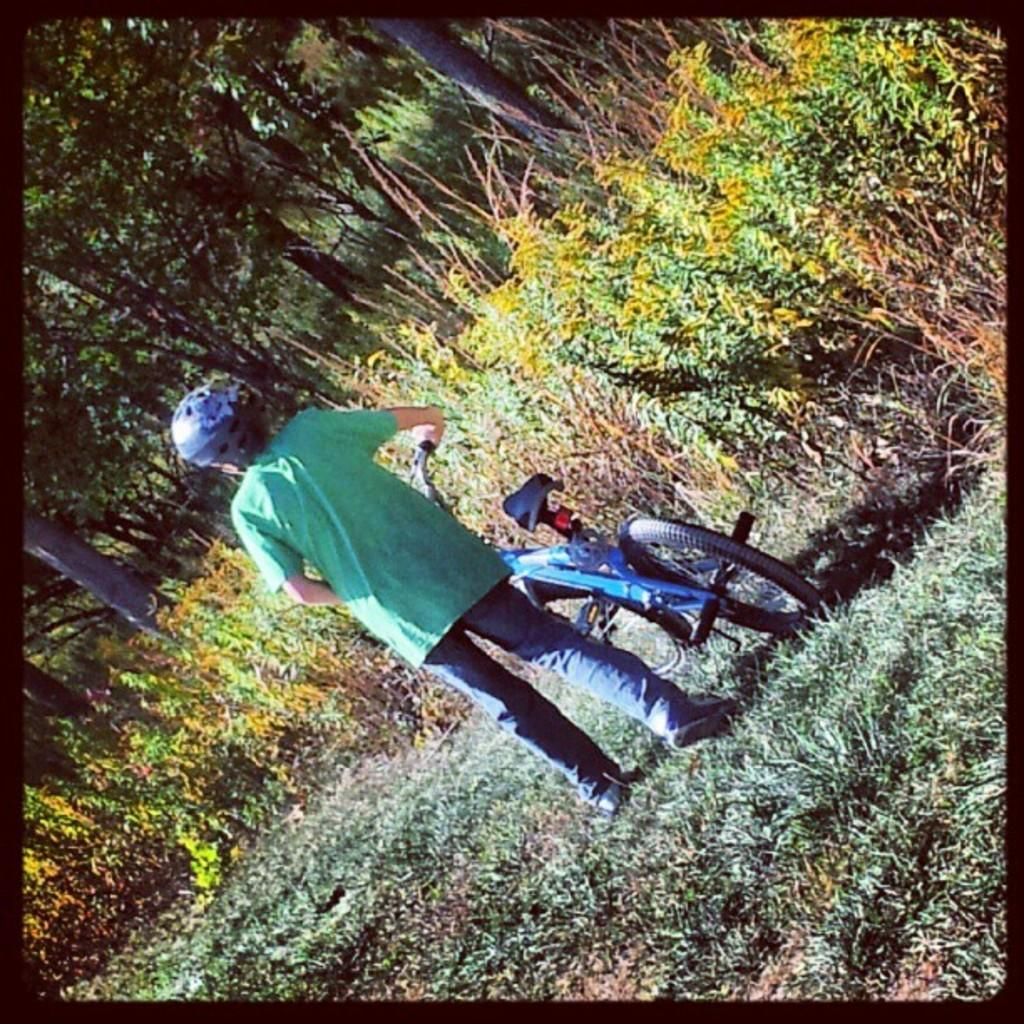What is the main subject of the image? The main subject of the image is a child. What is the child wearing? The child is wearing clothes, shoes, and a helmet. What is the child holding in the image? The child is holding a bike's handle. What type of vegetation can be seen in the image? There is grass, a plant, and trees visible in the image. What type of tray can be seen in the image? There is no tray present in the image. Is the child wearing a locket in the image? There is no mention of a locket in the image, and it cannot be determined from the provided facts. 